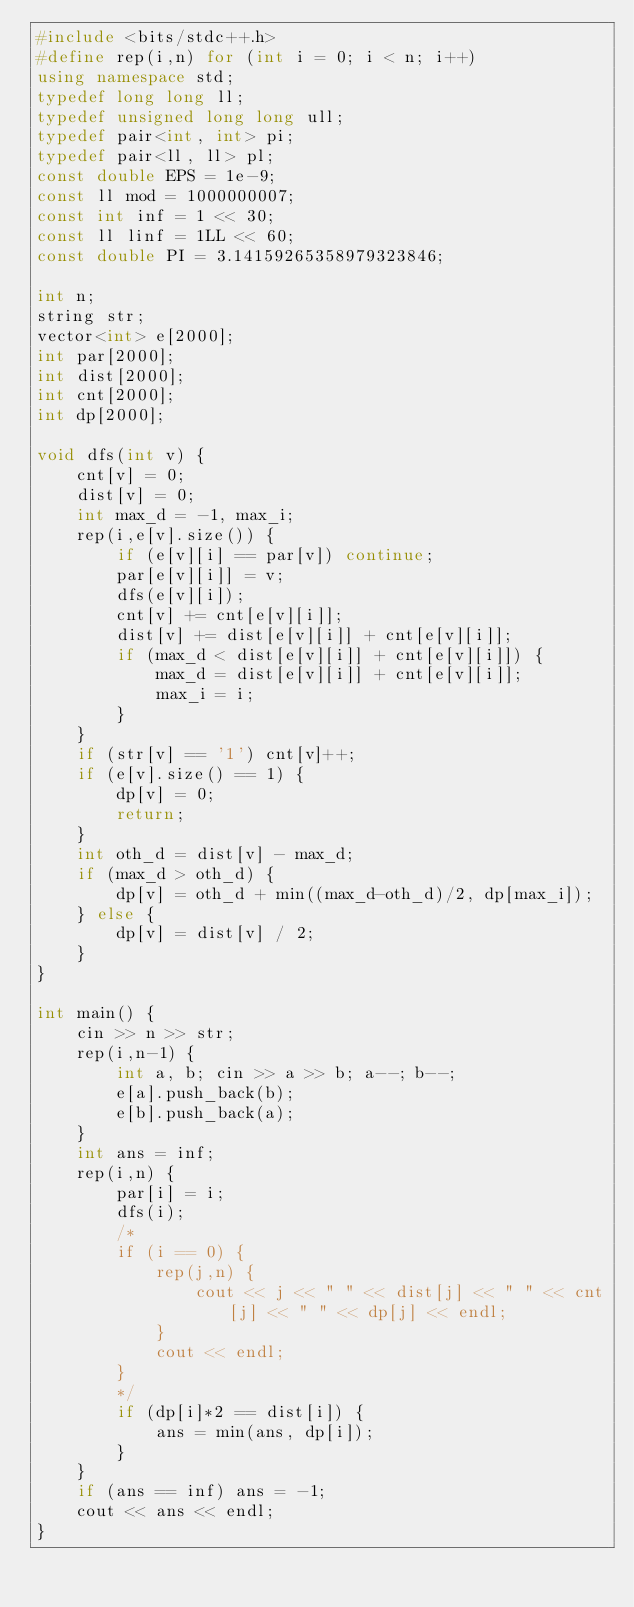Convert code to text. <code><loc_0><loc_0><loc_500><loc_500><_C++_>#include <bits/stdc++.h>
#define rep(i,n) for (int i = 0; i < n; i++)
using namespace std;
typedef long long ll;
typedef unsigned long long ull;
typedef pair<int, int> pi;
typedef pair<ll, ll> pl;
const double EPS = 1e-9;
const ll mod = 1000000007;
const int inf = 1 << 30;
const ll linf = 1LL << 60;
const double PI = 3.14159265358979323846;

int n;
string str;
vector<int> e[2000];
int par[2000];
int dist[2000];
int cnt[2000];
int dp[2000];

void dfs(int v) {
    cnt[v] = 0;
    dist[v] = 0;
    int max_d = -1, max_i;
    rep(i,e[v].size()) {
        if (e[v][i] == par[v]) continue;
        par[e[v][i]] = v;
        dfs(e[v][i]);
        cnt[v] += cnt[e[v][i]];
        dist[v] += dist[e[v][i]] + cnt[e[v][i]];
        if (max_d < dist[e[v][i]] + cnt[e[v][i]]) {
            max_d = dist[e[v][i]] + cnt[e[v][i]];
            max_i = i;
        }
    }
    if (str[v] == '1') cnt[v]++;
    if (e[v].size() == 1) {
        dp[v] = 0;
        return;
    }
    int oth_d = dist[v] - max_d;
    if (max_d > oth_d) {
        dp[v] = oth_d + min((max_d-oth_d)/2, dp[max_i]);
    } else {
        dp[v] = dist[v] / 2;
    }
}

int main() {
    cin >> n >> str;
    rep(i,n-1) {
        int a, b; cin >> a >> b; a--; b--;
        e[a].push_back(b);
        e[b].push_back(a);
    }
    int ans = inf;
    rep(i,n) {
        par[i] = i;
        dfs(i);
        /*
        if (i == 0) {
            rep(j,n) {
                cout << j << " " << dist[j] << " " << cnt[j] << " " << dp[j] << endl;
            }
            cout << endl;
        }
        */
        if (dp[i]*2 == dist[i]) {
            ans = min(ans, dp[i]);
        }
    }
    if (ans == inf) ans = -1;
    cout << ans << endl;
}</code> 